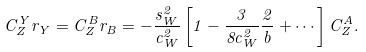<formula> <loc_0><loc_0><loc_500><loc_500>C _ { Z } ^ { Y } r _ { Y } = C _ { Z } ^ { B } r _ { B } = - \frac { s _ { W } ^ { 2 } } { c _ { W } ^ { 2 } } \left [ 1 - \frac { 3 } { 8 c _ { W } ^ { 2 } } \frac { 2 } { b } + \cdots \right ] C _ { Z } ^ { A } .</formula> 